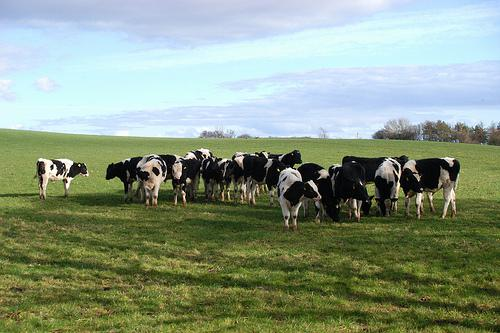Question: where was the picture taken?
Choices:
A. In a basement.
B. In an open field.
C. In a bathroom.
D. Kitchen.
Answer with the letter. Answer: B Question: how is the sky?
Choices:
A. Blue with clouds.
B. Dim.
C. Full of planes.
D. Overcast.
Answer with the letter. Answer: A Question: what is in the center?
Choices:
A. A cowboy.
B. Horses.
C. Cows.
D. Sheep.
Answer with the letter. Answer: C 